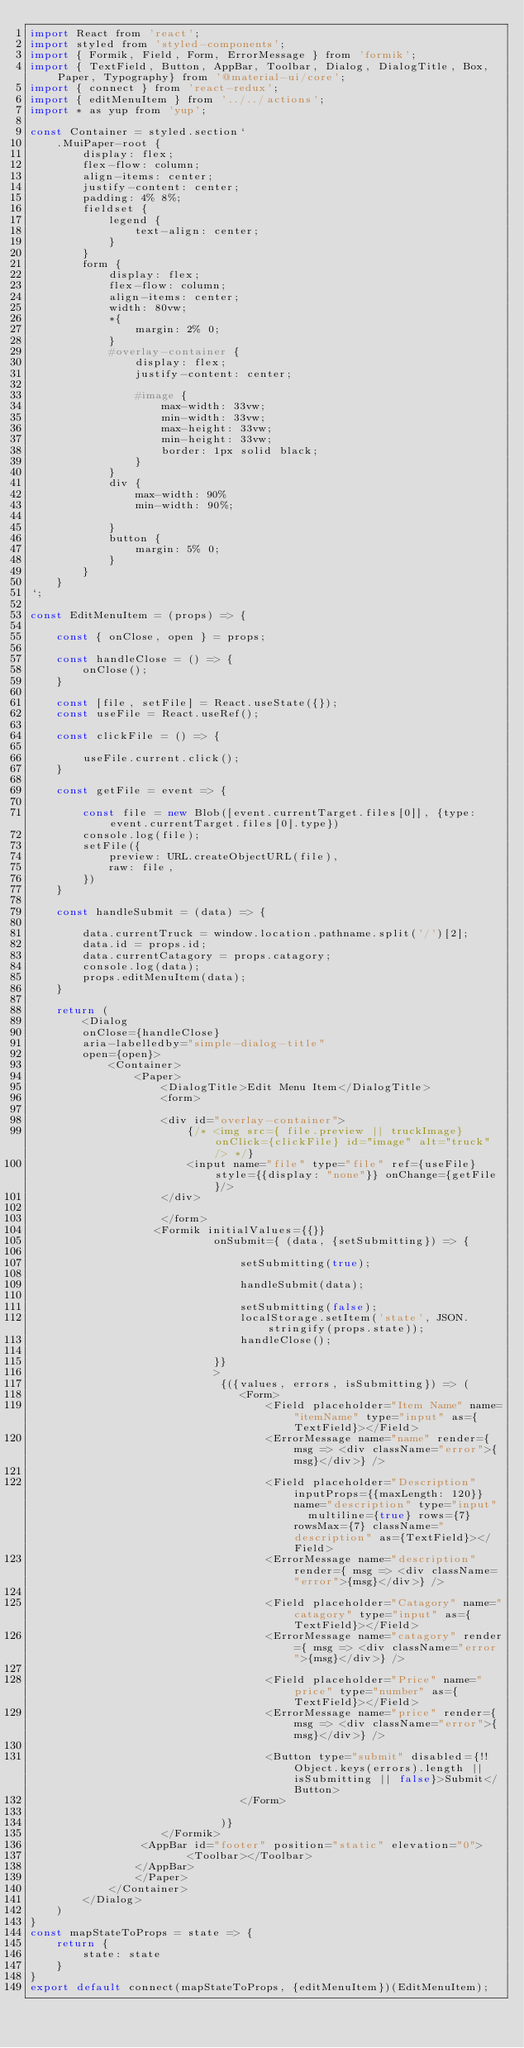Convert code to text. <code><loc_0><loc_0><loc_500><loc_500><_JavaScript_>import React from 'react';
import styled from 'styled-components';
import { Formik, Field, Form, ErrorMessage } from 'formik';
import { TextField, Button, AppBar, Toolbar, Dialog, DialogTitle, Box, Paper, Typography} from '@material-ui/core';
import { connect } from 'react-redux';
import { editMenuItem } from '../../actions';
import * as yup from 'yup';

const Container = styled.section`
    .MuiPaper-root {
        display: flex;
        flex-flow: column;
        align-items: center;
        justify-content: center;
        padding: 4% 8%;
        fieldset {
            legend {
                text-align: center;
            }
        }
        form {
            display: flex; 
            flex-flow: column;
            align-items: center;
            width: 80vw;
            *{
                margin: 2% 0;
            }
            #overlay-container { 
                display: flex;
                justify-content: center;
                
                #image {
                    max-width: 33vw;
                    min-width: 33vw;
                    max-height: 33vw;
                    min-height: 33vw;
                    border: 1px solid black;
                }
            }
            div {
                max-width: 90%
                min-width: 90%;
                
            }
            button {
                margin: 5% 0;
            }
        }
    }
`;

const EditMenuItem = (props) => {

    const { onClose, open } = props;

    const handleClose = () => {
        onClose();
    }
 
    const [file, setFile] = React.useState({});
    const useFile = React.useRef();

    const clickFile = () => {

        useFile.current.click();
    }

    const getFile = event => {

        const file = new Blob([event.currentTarget.files[0]], {type: event.currentTarget.files[0].type})
        console.log(file);
        setFile({
            preview: URL.createObjectURL(file),
            raw: file,
        })
    }

    const handleSubmit = (data) => {

        data.currentTruck = window.location.pathname.split('/')[2];
        data.id = props.id;
        data.currentCatagory = props.catagory;
        console.log(data);
        props.editMenuItem(data);
    }

    return (
        <Dialog 
        onClose={handleClose} 
        aria-labelledby="simple-dialog-title" 
        open={open}>
            <Container>
                <Paper>
                    <DialogTitle>Edit Menu Item</DialogTitle> 
                    <form>
              
                    <div id="overlay-container">
                        {/* <img src={ file.preview || truckImage} onClick={clickFile} id="image" alt="truck" /> */}
                        <input name="file" type="file" ref={useFile} style={{display: "none"}} onChange={getFile}/>
                    </div>      

                    </form>
                   <Formik initialValues={{}} 
                            onSubmit={ (data, {setSubmitting}) => {

                                setSubmitting(true);

                                handleSubmit(data);

                                setSubmitting(false);
                                localStorage.setItem('state', JSON.stringify(props.state));
                                handleClose();
                                
                            }}
                            >
                             {({values, errors, isSubmitting}) => (
                                <Form>
                                    <Field placeholder="Item Name" name="itemName" type="input" as={TextField}></Field>
                                    <ErrorMessage name="name" render={ msg => <div className="error">{msg}</div>} />

                                    <Field placeholder="Description" inputProps={{maxLength: 120}} name="description" type="input"  multiline={true} rows={7} rowsMax={7} className="description" as={TextField}></Field>
                                    <ErrorMessage name="description" render={ msg => <div className="error">{msg}</div>} />

                                    <Field placeholder="Catagory" name="catagory" type="input" as={TextField}></Field>
                                    <ErrorMessage name="catagory" render={ msg => <div className="error">{msg}</div>} />

                                    <Field placeholder="Price" name="price" type="number" as={TextField}></Field>
                                    <ErrorMessage name="price" render={ msg => <div className="error">{msg}</div>} />

                                    <Button type="submit" disabled={!!Object.keys(errors).length || isSubmitting || false}>Submit</Button>
                                </Form>
                                
                             )}
                    </Formik>       
                 <AppBar id="footer" position="static" elevation="0">
                        <Toolbar></Toolbar>
                </AppBar>
                </Paper>
            </Container>
        </Dialog>
    )
}
const mapStateToProps = state => {
    return {
        state: state 
    }
}
export default connect(mapStateToProps, {editMenuItem})(EditMenuItem);</code> 